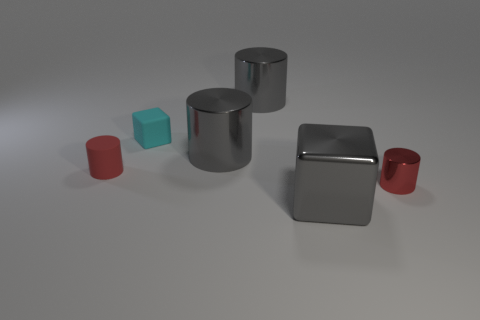Add 2 big yellow matte blocks. How many objects exist? 8 Subtract all cubes. How many objects are left? 4 Subtract 2 red cylinders. How many objects are left? 4 Subtract all purple balls. Subtract all tiny red cylinders. How many objects are left? 4 Add 2 small matte cubes. How many small matte cubes are left? 3 Add 4 metallic cubes. How many metallic cubes exist? 5 